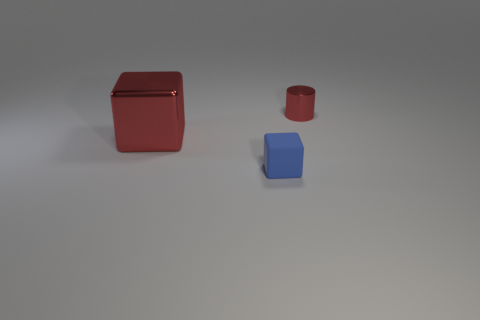Add 1 big red objects. How many objects exist? 4 Subtract all blocks. How many objects are left? 1 Subtract all large blue shiny cylinders. Subtract all red shiny blocks. How many objects are left? 2 Add 3 large red objects. How many large red objects are left? 4 Add 1 purple matte blocks. How many purple matte blocks exist? 1 Subtract 0 yellow spheres. How many objects are left? 3 